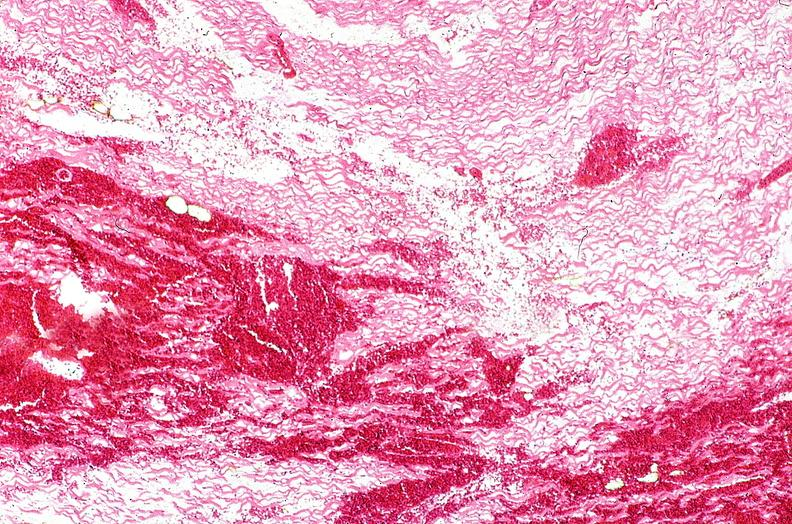what does this image show?
Answer the question using a single word or phrase. Heart 